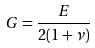Convert formula to latex. <formula><loc_0><loc_0><loc_500><loc_500>G = \frac { E } { 2 ( 1 + \nu ) }</formula> 